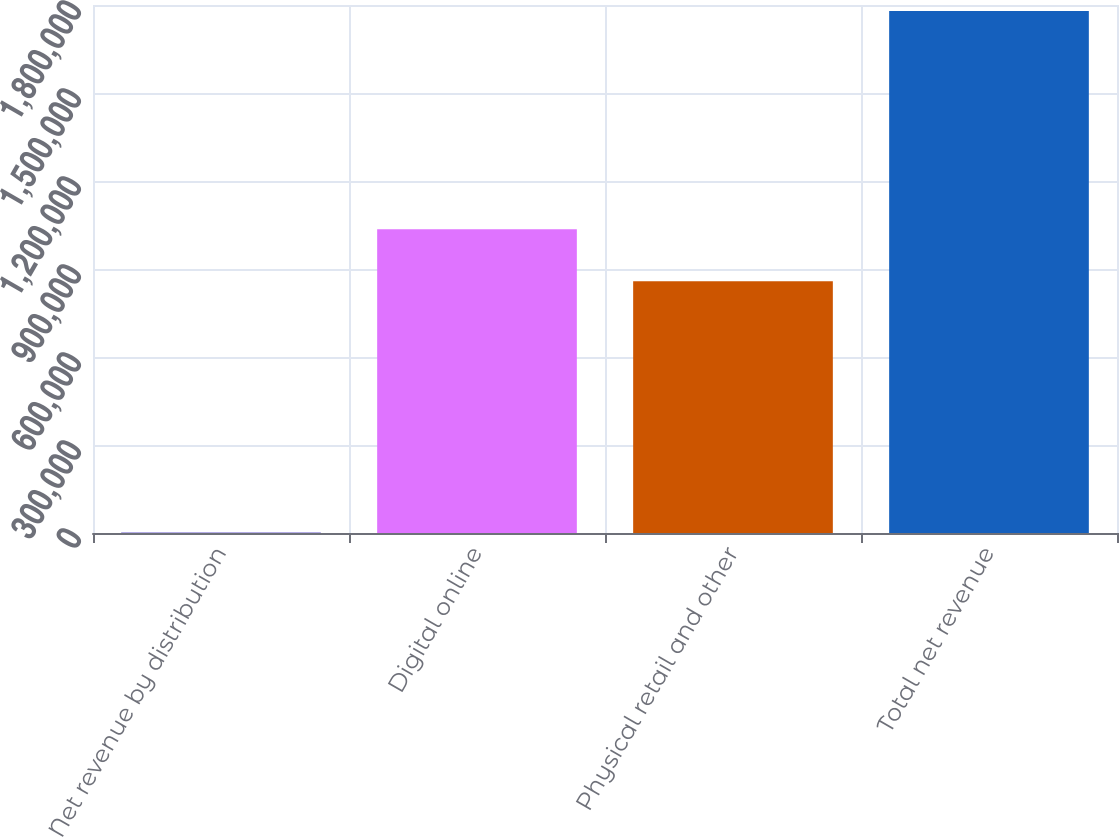<chart> <loc_0><loc_0><loc_500><loc_500><bar_chart><fcel>Net revenue by distribution<fcel>Digital online<fcel>Physical retail and other<fcel>Total net revenue<nl><fcel>2017<fcel>1.03579e+06<fcel>858014<fcel>1.77975e+06<nl></chart> 